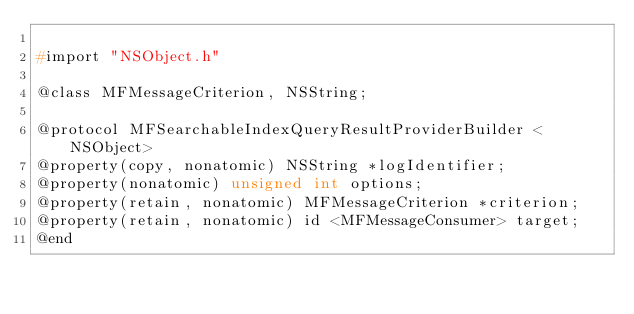<code> <loc_0><loc_0><loc_500><loc_500><_C_>
#import "NSObject.h"

@class MFMessageCriterion, NSString;

@protocol MFSearchableIndexQueryResultProviderBuilder <NSObject>
@property(copy, nonatomic) NSString *logIdentifier;
@property(nonatomic) unsigned int options;
@property(retain, nonatomic) MFMessageCriterion *criterion;
@property(retain, nonatomic) id <MFMessageConsumer> target;
@end

</code> 